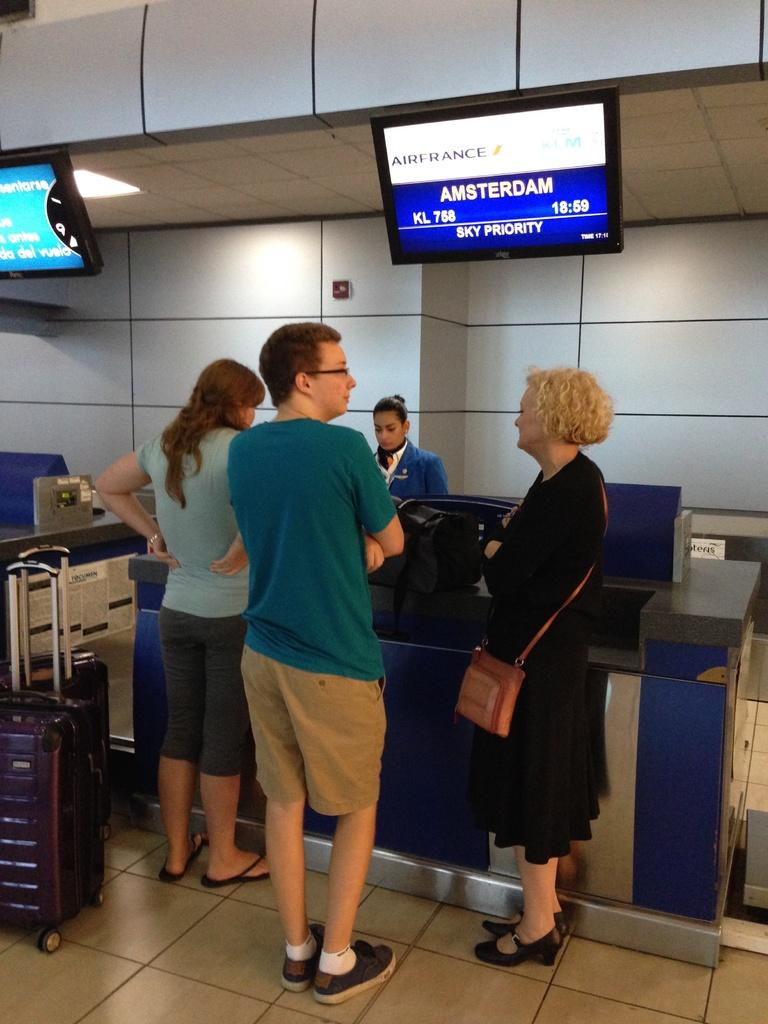How many people are in the image? There are three people in the image. What are the people doing in the image? The people are waiting in front of a counter. What additional information can be seen in the image? There are screens displaying time and place in the image. What might the people be waiting for, considering the presence of luggage? The people might be waiting for a service related to their luggage, such as checking in for a flight or train. What type of pies are being served at the counter in the image? There is no indication of pies being served in the image; the people are waiting in front of a counter, but the purpose of the counter is not specified. 